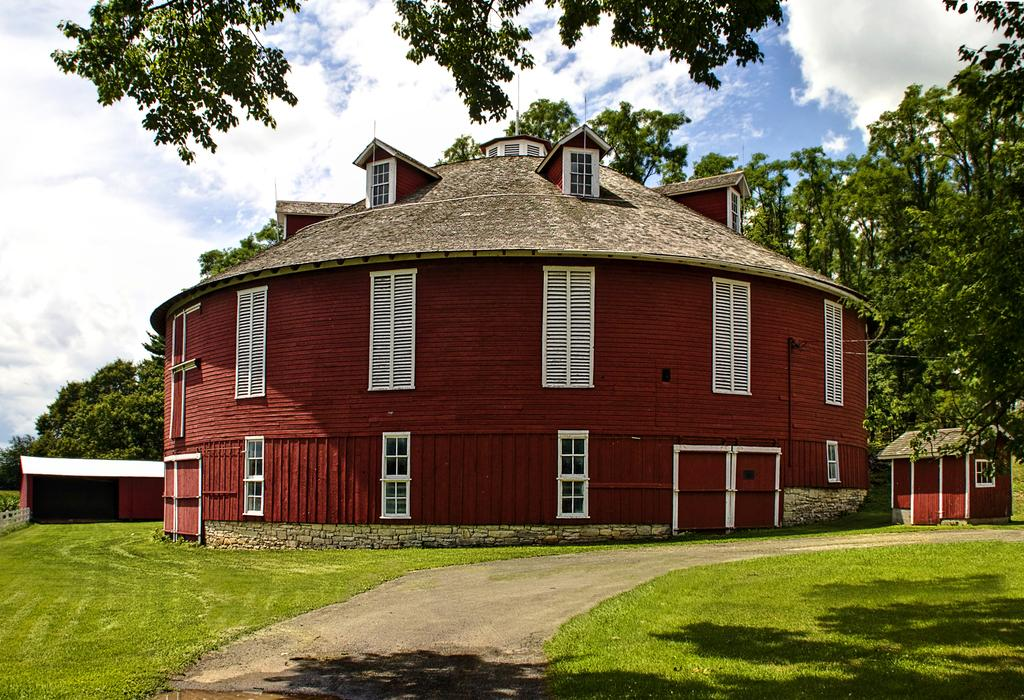What type of vegetation can be seen in the image? There is grass in the image. What structures are visible in the image? There are buildings in the image. What architectural feature can be seen on the buildings? Windows are visible in the image. What other natural elements can be seen in the image? There are trees in the image. What part of the natural environment is visible in the image? The sky is visible in the image. What atmospheric conditions can be observed in the sky? Clouds are present in the sky. Can you tell me how many worms are crawling on the stranger's team in the image? There is no stranger or team present in the image, and therefore no worms can be observed. 